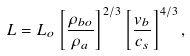Convert formula to latex. <formula><loc_0><loc_0><loc_500><loc_500>L = L _ { o } \left [ \frac { \rho _ { b o } } { \rho _ { a } } \right ] ^ { 2 / 3 } \left [ \frac { v _ { b } } { c _ { s } } \right ] ^ { 4 / 3 } ,</formula> 